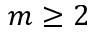<formula> <loc_0><loc_0><loc_500><loc_500>m \geq 2</formula> 